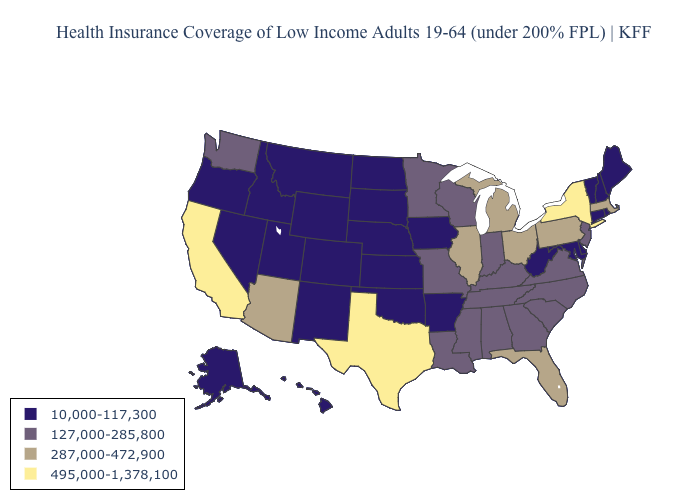What is the value of Arkansas?
Short answer required. 10,000-117,300. What is the value of Montana?
Concise answer only. 10,000-117,300. Does California have the lowest value in the West?
Give a very brief answer. No. Among the states that border New Mexico , which have the lowest value?
Concise answer only. Colorado, Oklahoma, Utah. Does West Virginia have the same value as Michigan?
Give a very brief answer. No. Among the states that border Maryland , does Delaware have the highest value?
Write a very short answer. No. What is the value of New Jersey?
Write a very short answer. 127,000-285,800. What is the highest value in the South ?
Give a very brief answer. 495,000-1,378,100. Does the map have missing data?
Quick response, please. No. Among the states that border Florida , which have the lowest value?
Keep it brief. Alabama, Georgia. Name the states that have a value in the range 495,000-1,378,100?
Be succinct. California, New York, Texas. Name the states that have a value in the range 495,000-1,378,100?
Short answer required. California, New York, Texas. Which states hav the highest value in the South?
Quick response, please. Texas. Name the states that have a value in the range 127,000-285,800?
Write a very short answer. Alabama, Georgia, Indiana, Kentucky, Louisiana, Minnesota, Mississippi, Missouri, New Jersey, North Carolina, South Carolina, Tennessee, Virginia, Washington, Wisconsin. Does Louisiana have the same value as Alabama?
Keep it brief. Yes. 